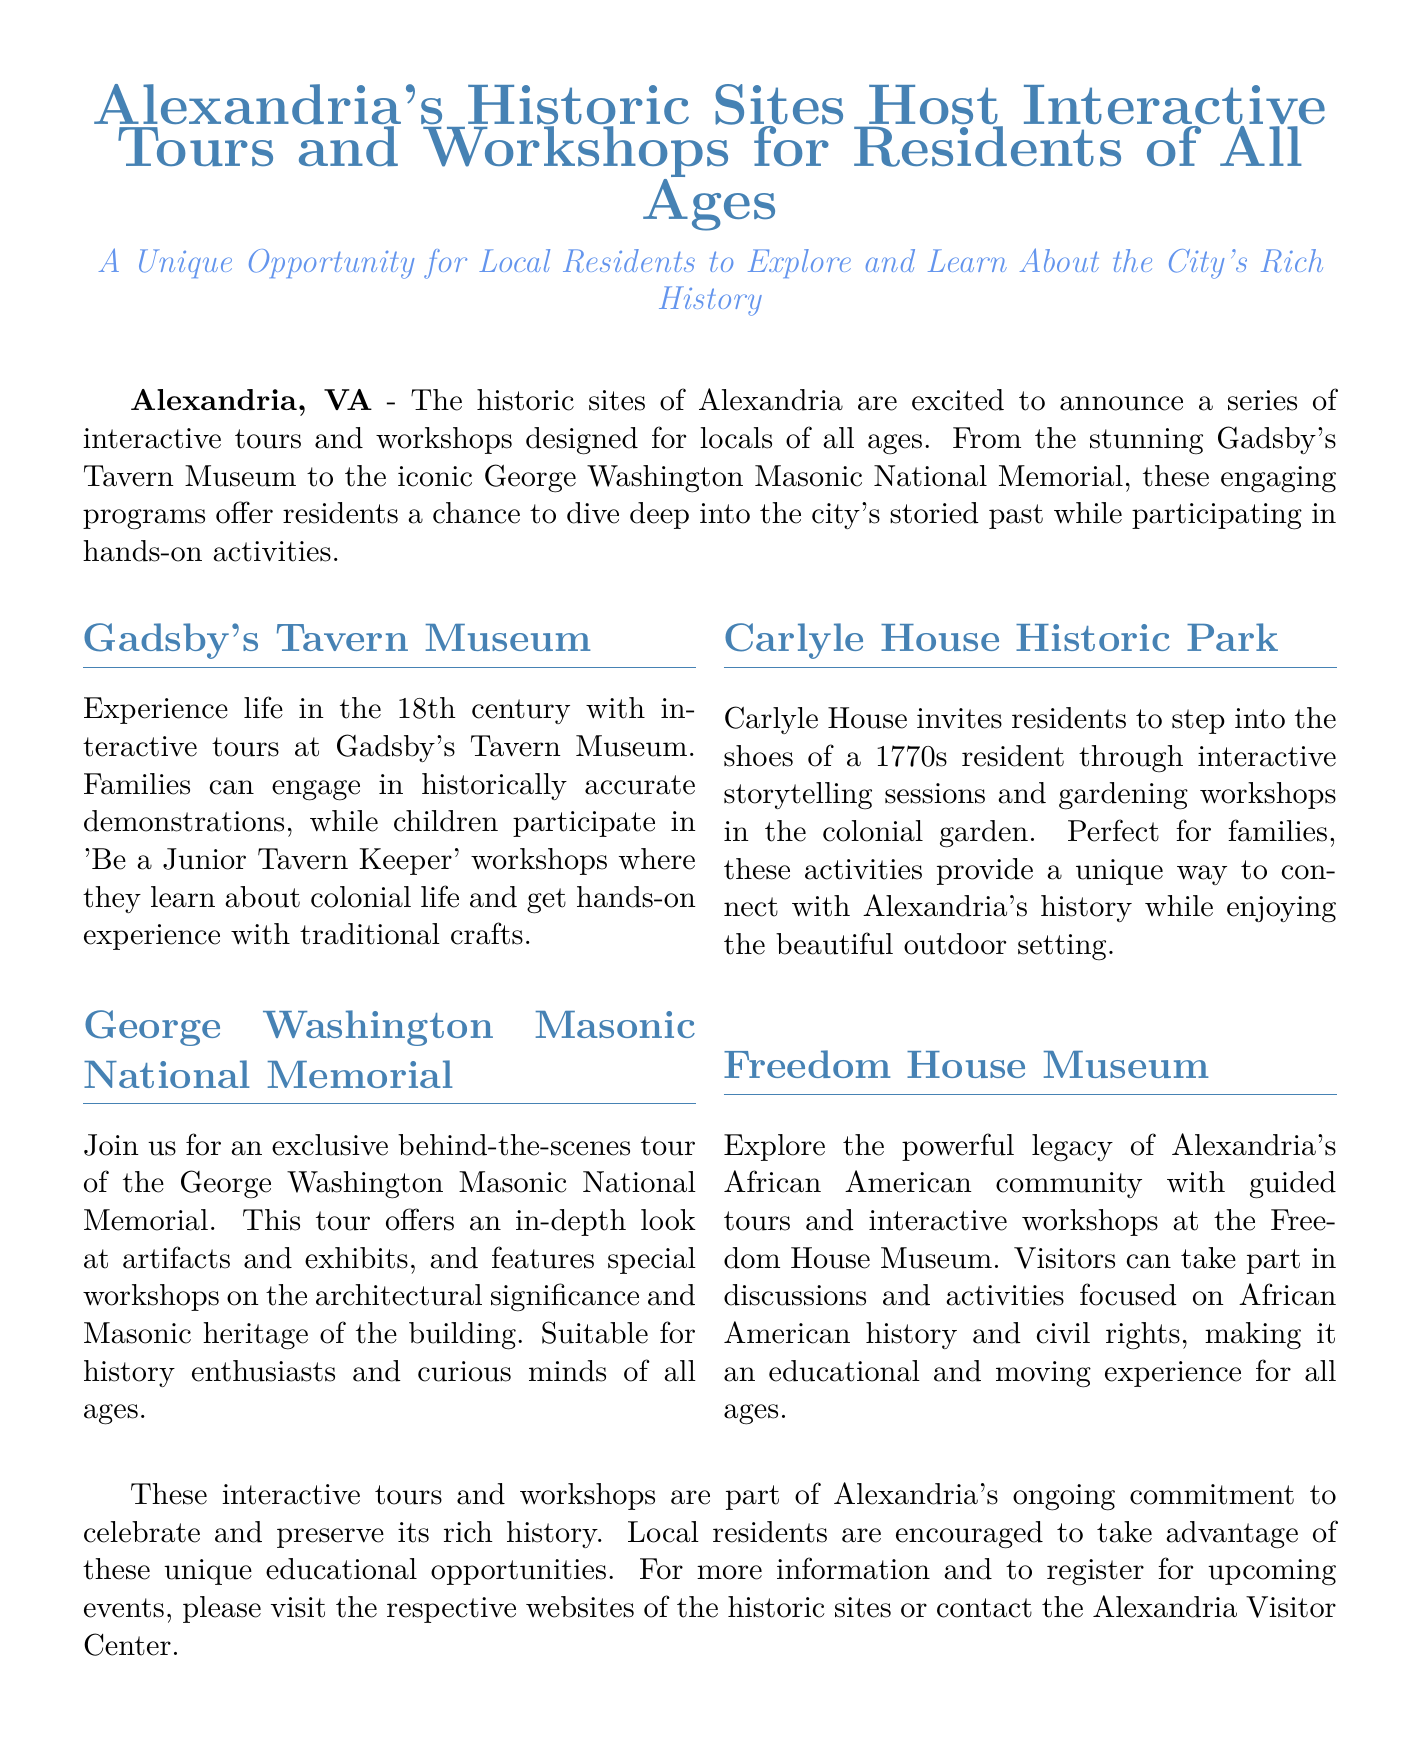What historic site features 'Be a Junior Tavern Keeper' workshops? The workshops are part of the activities offered at Gadsby's Tavern Museum, where children learn about colonial life and participate in traditional crafts.
Answer: Gadsby's Tavern Museum Which historic site focuses on African American history? The Freedom House Museum offers guided tours and interactive workshops centered on the powerful legacy of Alexandria's African American community.
Answer: Freedom House Museum What type of program is offered at Carlyle House? Carlyle House invites residents to enjoy interactive storytelling sessions and gardening workshops in the colonial garden, connecting with Alexandria's history.
Answer: Storytelling sessions and gardening workshops Where can residents register for the events? Residents can register for the upcoming tours and workshops by visiting the respective websites of the historic sites or contacting the Alexandria Visitor Center.
Answer: Websites of the historic sites or Alexandria Visitor Center What age groups are the interactive tours and workshops aimed at? The programs are designed for locals of all ages, making them accessible and engaging for everyone in the community.
Answer: All ages 